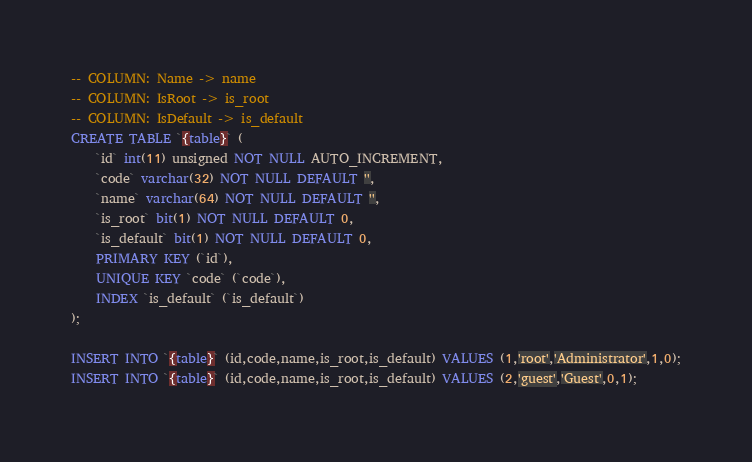<code> <loc_0><loc_0><loc_500><loc_500><_SQL_>-- COLUMN: Name -> name
-- COLUMN: IsRoot -> is_root
-- COLUMN: IsDefault -> is_default
CREATE TABLE `{table}` (
	`id` int(11) unsigned NOT NULL AUTO_INCREMENT,
	`code` varchar(32) NOT NULL DEFAULT '',
	`name` varchar(64) NOT NULL DEFAULT '',
	`is_root` bit(1) NOT NULL DEFAULT 0,
	`is_default` bit(1) NOT NULL DEFAULT 0,
	PRIMARY KEY (`id`),
	UNIQUE KEY `code` (`code`),
	INDEX `is_default` (`is_default`)
);

INSERT INTO `{table}` (id,code,name,is_root,is_default) VALUES (1,'root','Administrator',1,0);
INSERT INTO `{table}` (id,code,name,is_root,is_default) VALUES (2,'guest','Guest',0,1);
</code> 